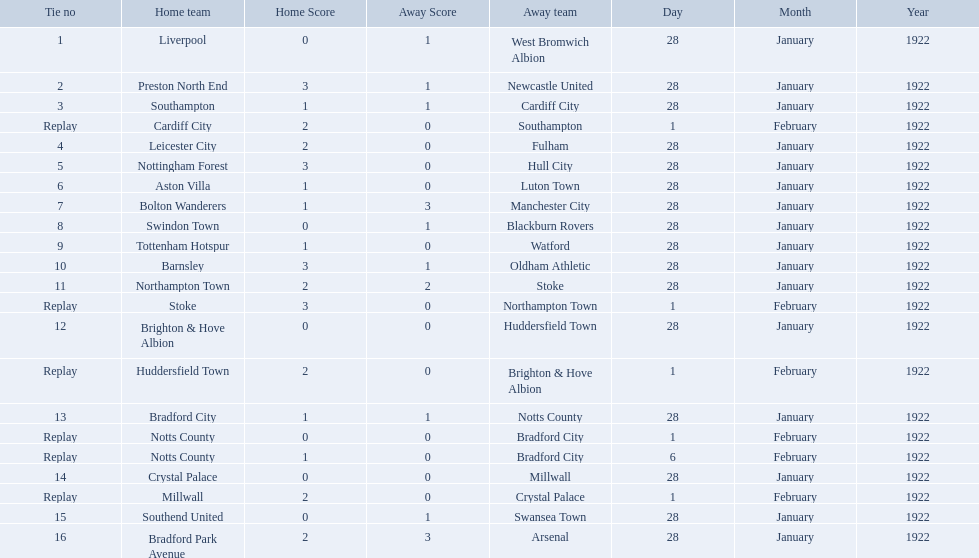What was the score in the aston villa game? 1–0. Which other team had an identical score? Tottenham Hotspur. 